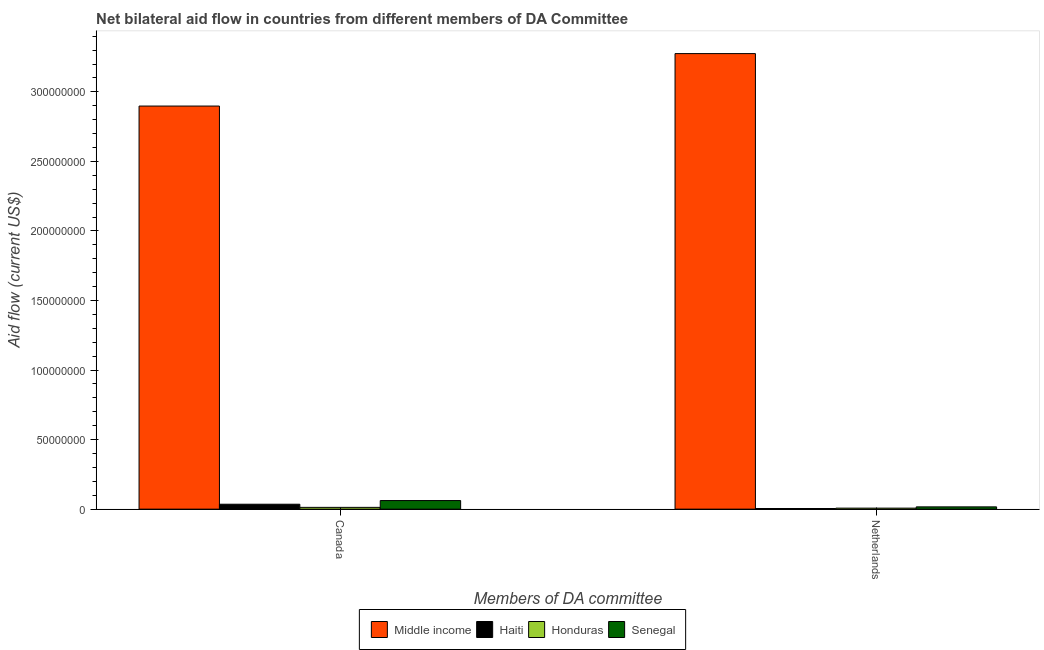How many different coloured bars are there?
Offer a terse response. 4. Are the number of bars on each tick of the X-axis equal?
Ensure brevity in your answer.  Yes. How many bars are there on the 1st tick from the left?
Ensure brevity in your answer.  4. How many bars are there on the 1st tick from the right?
Provide a succinct answer. 4. What is the label of the 1st group of bars from the left?
Provide a short and direct response. Canada. What is the amount of aid given by netherlands in Haiti?
Offer a terse response. 4.60e+05. Across all countries, what is the maximum amount of aid given by netherlands?
Offer a very short reply. 3.28e+08. Across all countries, what is the minimum amount of aid given by canada?
Provide a short and direct response. 1.28e+06. In which country was the amount of aid given by netherlands maximum?
Ensure brevity in your answer.  Middle income. In which country was the amount of aid given by netherlands minimum?
Your answer should be very brief. Haiti. What is the total amount of aid given by netherlands in the graph?
Offer a very short reply. 3.30e+08. What is the difference between the amount of aid given by canada in Middle income and that in Haiti?
Keep it short and to the point. 2.86e+08. What is the difference between the amount of aid given by netherlands in Senegal and the amount of aid given by canada in Honduras?
Give a very brief answer. 3.60e+05. What is the average amount of aid given by canada per country?
Make the answer very short. 7.52e+07. What is the difference between the amount of aid given by canada and amount of aid given by netherlands in Middle income?
Provide a short and direct response. -3.77e+07. In how many countries, is the amount of aid given by canada greater than 300000000 US$?
Offer a very short reply. 0. What is the ratio of the amount of aid given by netherlands in Honduras to that in Middle income?
Keep it short and to the point. 0. What does the 3rd bar from the left in Canada represents?
Ensure brevity in your answer.  Honduras. What does the 1st bar from the right in Netherlands represents?
Your response must be concise. Senegal. Are all the bars in the graph horizontal?
Give a very brief answer. No. What is the difference between two consecutive major ticks on the Y-axis?
Provide a short and direct response. 5.00e+07. Does the graph contain grids?
Your response must be concise. No. What is the title of the graph?
Offer a terse response. Net bilateral aid flow in countries from different members of DA Committee. What is the label or title of the X-axis?
Offer a terse response. Members of DA committee. What is the Aid flow (current US$) in Middle income in Canada?
Provide a succinct answer. 2.90e+08. What is the Aid flow (current US$) of Haiti in Canada?
Your response must be concise. 3.54e+06. What is the Aid flow (current US$) of Honduras in Canada?
Offer a very short reply. 1.28e+06. What is the Aid flow (current US$) in Senegal in Canada?
Your answer should be very brief. 6.18e+06. What is the Aid flow (current US$) of Middle income in Netherlands?
Your response must be concise. 3.28e+08. What is the Aid flow (current US$) in Haiti in Netherlands?
Provide a short and direct response. 4.60e+05. What is the Aid flow (current US$) of Honduras in Netherlands?
Your response must be concise. 7.30e+05. What is the Aid flow (current US$) in Senegal in Netherlands?
Your answer should be very brief. 1.64e+06. Across all Members of DA committee, what is the maximum Aid flow (current US$) in Middle income?
Provide a succinct answer. 3.28e+08. Across all Members of DA committee, what is the maximum Aid flow (current US$) in Haiti?
Keep it short and to the point. 3.54e+06. Across all Members of DA committee, what is the maximum Aid flow (current US$) in Honduras?
Give a very brief answer. 1.28e+06. Across all Members of DA committee, what is the maximum Aid flow (current US$) in Senegal?
Give a very brief answer. 6.18e+06. Across all Members of DA committee, what is the minimum Aid flow (current US$) in Middle income?
Offer a terse response. 2.90e+08. Across all Members of DA committee, what is the minimum Aid flow (current US$) in Haiti?
Provide a succinct answer. 4.60e+05. Across all Members of DA committee, what is the minimum Aid flow (current US$) in Honduras?
Your answer should be compact. 7.30e+05. Across all Members of DA committee, what is the minimum Aid flow (current US$) of Senegal?
Your answer should be very brief. 1.64e+06. What is the total Aid flow (current US$) of Middle income in the graph?
Provide a succinct answer. 6.17e+08. What is the total Aid flow (current US$) in Honduras in the graph?
Your answer should be very brief. 2.01e+06. What is the total Aid flow (current US$) of Senegal in the graph?
Give a very brief answer. 7.82e+06. What is the difference between the Aid flow (current US$) in Middle income in Canada and that in Netherlands?
Offer a terse response. -3.77e+07. What is the difference between the Aid flow (current US$) of Haiti in Canada and that in Netherlands?
Provide a short and direct response. 3.08e+06. What is the difference between the Aid flow (current US$) in Honduras in Canada and that in Netherlands?
Provide a succinct answer. 5.50e+05. What is the difference between the Aid flow (current US$) in Senegal in Canada and that in Netherlands?
Offer a terse response. 4.54e+06. What is the difference between the Aid flow (current US$) of Middle income in Canada and the Aid flow (current US$) of Haiti in Netherlands?
Keep it short and to the point. 2.89e+08. What is the difference between the Aid flow (current US$) in Middle income in Canada and the Aid flow (current US$) in Honduras in Netherlands?
Your answer should be very brief. 2.89e+08. What is the difference between the Aid flow (current US$) of Middle income in Canada and the Aid flow (current US$) of Senegal in Netherlands?
Make the answer very short. 2.88e+08. What is the difference between the Aid flow (current US$) of Haiti in Canada and the Aid flow (current US$) of Honduras in Netherlands?
Your answer should be compact. 2.81e+06. What is the difference between the Aid flow (current US$) in Haiti in Canada and the Aid flow (current US$) in Senegal in Netherlands?
Your response must be concise. 1.90e+06. What is the difference between the Aid flow (current US$) of Honduras in Canada and the Aid flow (current US$) of Senegal in Netherlands?
Give a very brief answer. -3.60e+05. What is the average Aid flow (current US$) of Middle income per Members of DA committee?
Offer a very short reply. 3.09e+08. What is the average Aid flow (current US$) in Honduras per Members of DA committee?
Your answer should be compact. 1.00e+06. What is the average Aid flow (current US$) in Senegal per Members of DA committee?
Provide a succinct answer. 3.91e+06. What is the difference between the Aid flow (current US$) in Middle income and Aid flow (current US$) in Haiti in Canada?
Your answer should be very brief. 2.86e+08. What is the difference between the Aid flow (current US$) of Middle income and Aid flow (current US$) of Honduras in Canada?
Your answer should be very brief. 2.89e+08. What is the difference between the Aid flow (current US$) in Middle income and Aid flow (current US$) in Senegal in Canada?
Your response must be concise. 2.84e+08. What is the difference between the Aid flow (current US$) in Haiti and Aid flow (current US$) in Honduras in Canada?
Offer a very short reply. 2.26e+06. What is the difference between the Aid flow (current US$) in Haiti and Aid flow (current US$) in Senegal in Canada?
Make the answer very short. -2.64e+06. What is the difference between the Aid flow (current US$) in Honduras and Aid flow (current US$) in Senegal in Canada?
Keep it short and to the point. -4.90e+06. What is the difference between the Aid flow (current US$) in Middle income and Aid flow (current US$) in Haiti in Netherlands?
Offer a very short reply. 3.27e+08. What is the difference between the Aid flow (current US$) of Middle income and Aid flow (current US$) of Honduras in Netherlands?
Offer a terse response. 3.27e+08. What is the difference between the Aid flow (current US$) in Middle income and Aid flow (current US$) in Senegal in Netherlands?
Offer a very short reply. 3.26e+08. What is the difference between the Aid flow (current US$) of Haiti and Aid flow (current US$) of Honduras in Netherlands?
Offer a terse response. -2.70e+05. What is the difference between the Aid flow (current US$) in Haiti and Aid flow (current US$) in Senegal in Netherlands?
Provide a succinct answer. -1.18e+06. What is the difference between the Aid flow (current US$) in Honduras and Aid flow (current US$) in Senegal in Netherlands?
Keep it short and to the point. -9.10e+05. What is the ratio of the Aid flow (current US$) in Middle income in Canada to that in Netherlands?
Your answer should be compact. 0.88. What is the ratio of the Aid flow (current US$) of Haiti in Canada to that in Netherlands?
Offer a very short reply. 7.7. What is the ratio of the Aid flow (current US$) of Honduras in Canada to that in Netherlands?
Make the answer very short. 1.75. What is the ratio of the Aid flow (current US$) of Senegal in Canada to that in Netherlands?
Provide a succinct answer. 3.77. What is the difference between the highest and the second highest Aid flow (current US$) of Middle income?
Offer a very short reply. 3.77e+07. What is the difference between the highest and the second highest Aid flow (current US$) of Haiti?
Offer a terse response. 3.08e+06. What is the difference between the highest and the second highest Aid flow (current US$) of Honduras?
Provide a succinct answer. 5.50e+05. What is the difference between the highest and the second highest Aid flow (current US$) of Senegal?
Offer a terse response. 4.54e+06. What is the difference between the highest and the lowest Aid flow (current US$) of Middle income?
Ensure brevity in your answer.  3.77e+07. What is the difference between the highest and the lowest Aid flow (current US$) in Haiti?
Provide a succinct answer. 3.08e+06. What is the difference between the highest and the lowest Aid flow (current US$) in Senegal?
Keep it short and to the point. 4.54e+06. 